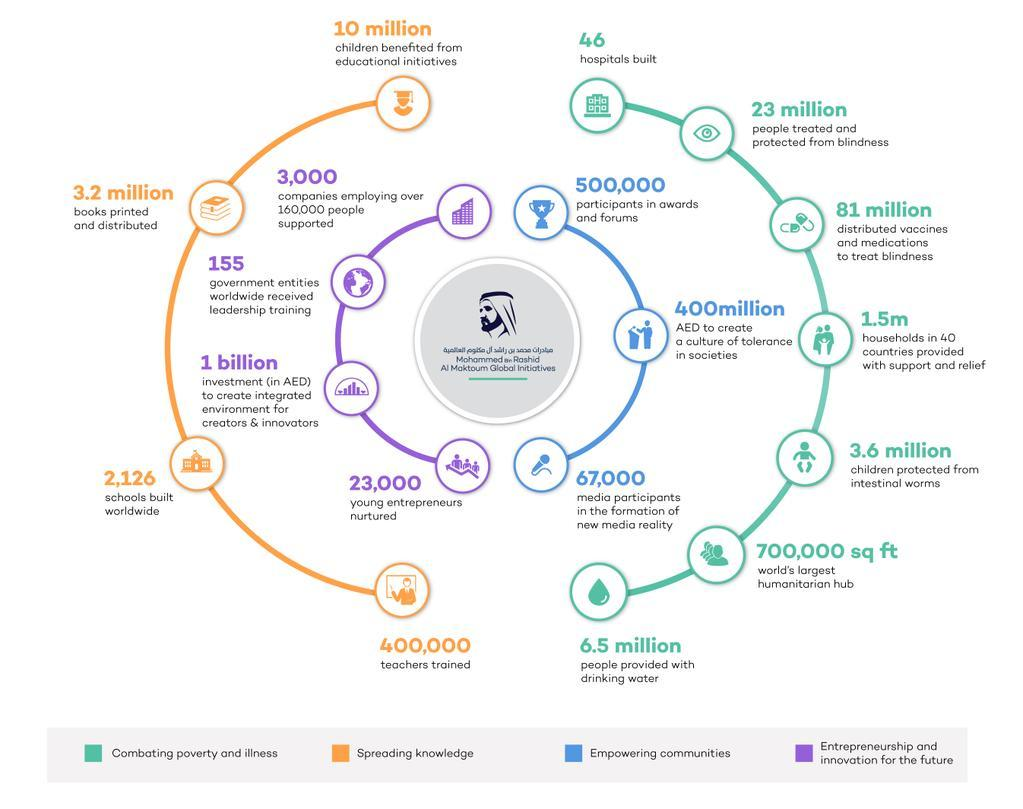How many government entities worlwide received leadership training as a part of Mohammed bin Rashid Al Maktoum Global Initiative?
Answer the question with a short phrase. 155 How many teachers were trained by MBRGI foundation? 400,000 How many schools were built worlwide by Mohammed bin Rashid Al Maktoum Global Initiatives (MBRGI) foundation? 2,126 How many people were provided with drinking water by Mohammed bin Rashid Al Maktoum Global Initiatives (MBRGI) foundation? 6.5 million How many young entrepreneurs were nurtured by Mohammed bin Rashid Al Maktoum Global Initiative foundation? 23,000 How many hospitals were build globally as a part of Mohammed bin Rashid Al Maktoum Global Initiative? 46 